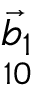<formula> <loc_0><loc_0><loc_500><loc_500>\underset { 1 0 } { \ V e c { b } _ { 1 } }</formula> 